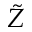<formula> <loc_0><loc_0><loc_500><loc_500>\tilde { Z }</formula> 